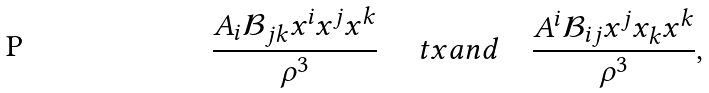<formula> <loc_0><loc_0><loc_500><loc_500>\frac { A _ { i } \mathcal { B } _ { j k } x ^ { i } x ^ { j } x ^ { k } } { \rho ^ { 3 } } \quad \ t x { a n d } \quad \frac { A ^ { i } \mathcal { B } _ { i j } x ^ { j } x _ { k } x ^ { k } } { \rho ^ { 3 } } ,</formula> 